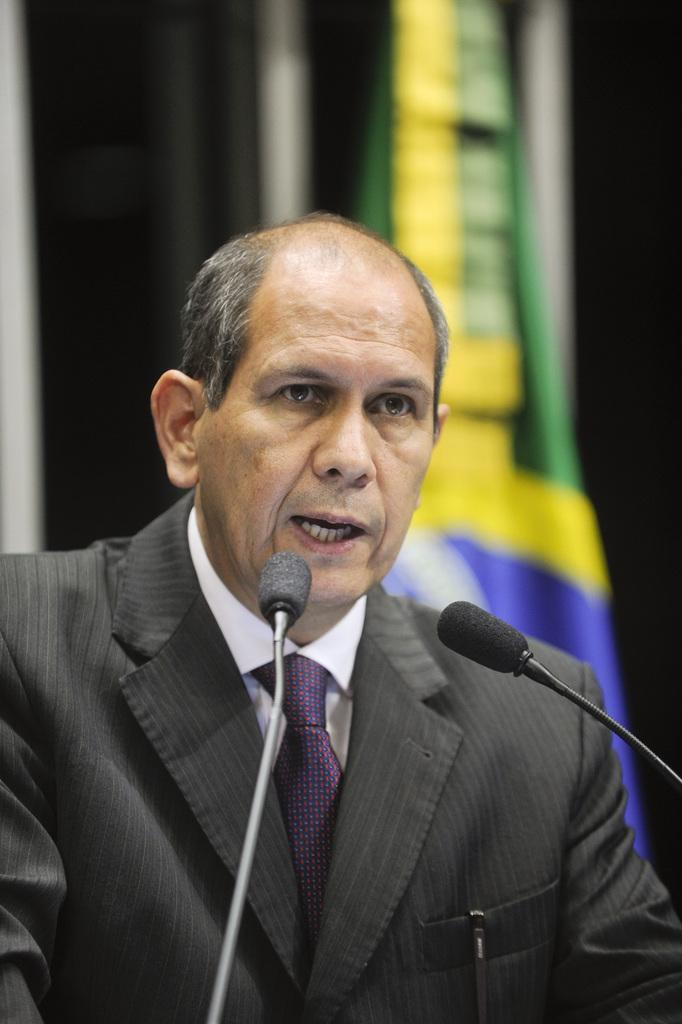Who is present in the image? There is a man in the image. What is the man wearing? The man is wearing a suit. What can be seen in the background of the image? There is a flag in the background of the image. What else is visible in the image? Miles are visible in the image. How many fingers can be seen on the man's sock in the image? There is no mention of a sock or fingers on a sock in the image. 